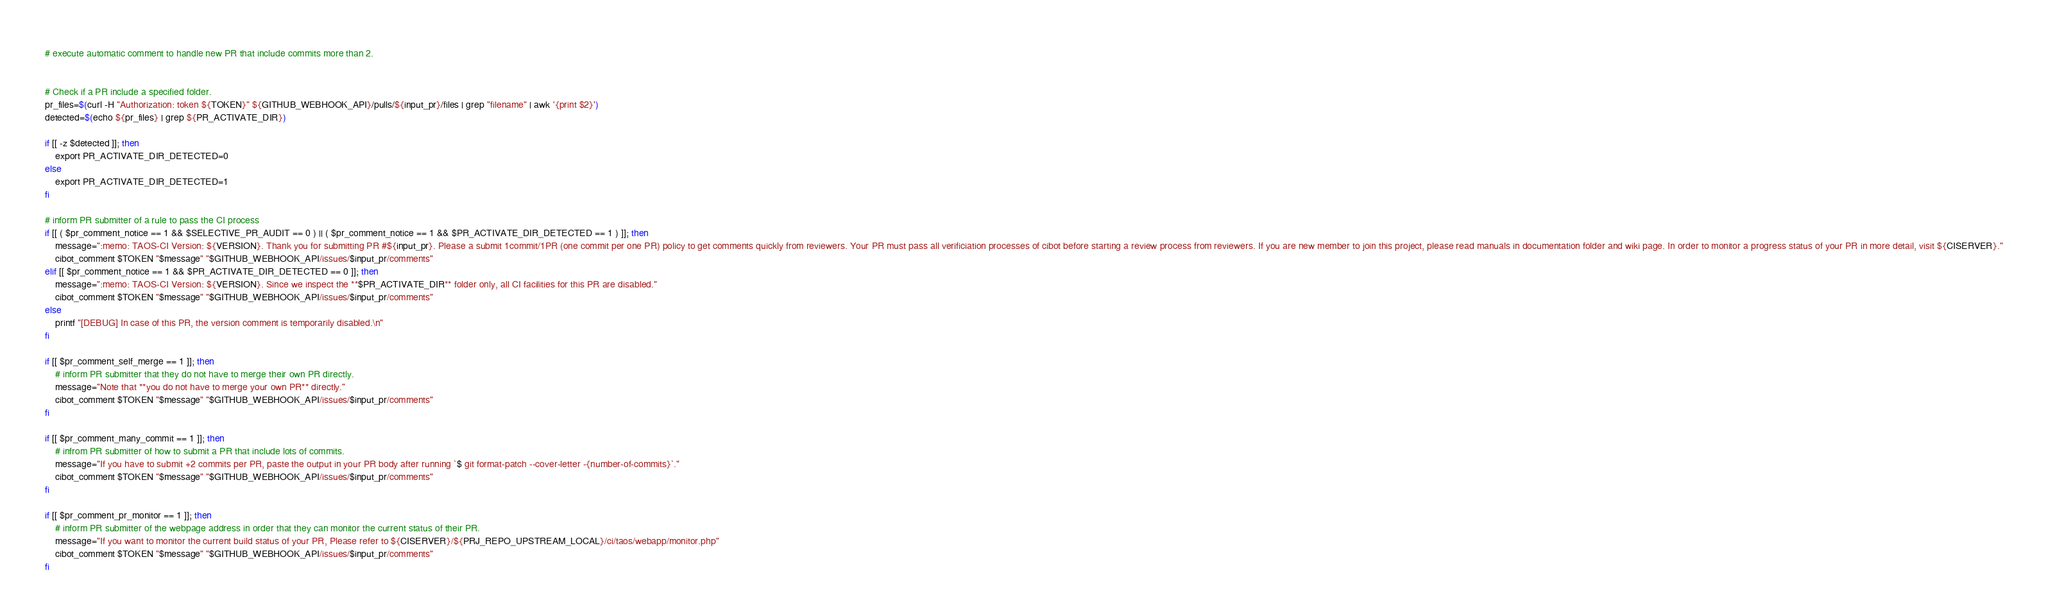<code> <loc_0><loc_0><loc_500><loc_500><_Bash_># execute automatic comment to handle new PR that include commits more than 2.


# Check if a PR include a specified folder.
pr_files=$(curl -H "Authorization: token ${TOKEN}" ${GITHUB_WEBHOOK_API}/pulls/${input_pr}/files | grep "filename" | awk '{print $2}')
detected=$(echo ${pr_files} | grep ${PR_ACTIVATE_DIR})

if [[ -z $detected ]]; then
    export PR_ACTIVATE_DIR_DETECTED=0
else
    export PR_ACTIVATE_DIR_DETECTED=1
fi

# inform PR submitter of a rule to pass the CI process
if [[ ( $pr_comment_notice == 1 && $SELECTIVE_PR_AUDIT == 0 ) || ( $pr_comment_notice == 1 && $PR_ACTIVATE_DIR_DETECTED == 1 ) ]]; then
    message=":memo: TAOS-CI Version: ${VERSION}. Thank you for submitting PR #${input_pr}. Please a submit 1commit/1PR (one commit per one PR) policy to get comments quickly from reviewers. Your PR must pass all verificiation processes of cibot before starting a review process from reviewers. If you are new member to join this project, please read manuals in documentation folder and wiki page. In order to monitor a progress status of your PR in more detail, visit ${CISERVER}."
    cibot_comment $TOKEN "$message" "$GITHUB_WEBHOOK_API/issues/$input_pr/comments"
elif [[ $pr_comment_notice == 1 && $PR_ACTIVATE_DIR_DETECTED == 0 ]]; then
    message=":memo: TAOS-CI Version: ${VERSION}. Since we inspect the **$PR_ACTIVATE_DIR** folder only, all CI facilities for this PR are disabled."
    cibot_comment $TOKEN "$message" "$GITHUB_WEBHOOK_API/issues/$input_pr/comments"
else
    printf "[DEBUG] In case of this PR, the version comment is temporarily disabled.\n"
fi

if [[ $pr_comment_self_merge == 1 ]]; then
    # inform PR submitter that they do not have to merge their own PR directly.
    message="Note that **you do not have to merge your own PR** directly."
    cibot_comment $TOKEN "$message" "$GITHUB_WEBHOOK_API/issues/$input_pr/comments"
fi

if [[ $pr_comment_many_commit == 1 ]]; then
    # infrom PR submitter of how to submit a PR that include lots of commits.
    message="If you have to submit +2 commits per PR, paste the output in your PR body after running `$ git format-patch --cover-letter -{number-of-commits}`."
    cibot_comment $TOKEN "$message" "$GITHUB_WEBHOOK_API/issues/$input_pr/comments"
fi

if [[ $pr_comment_pr_monitor == 1 ]]; then
    # inform PR submitter of the webpage address in order that they can monitor the current status of their PR.
    message="If you want to monitor the current build status of your PR, Please refer to ${CISERVER}/${PRJ_REPO_UPSTREAM_LOCAL}/ci/taos/webapp/monitor.php"
    cibot_comment $TOKEN "$message" "$GITHUB_WEBHOOK_API/issues/$input_pr/comments"
fi

</code> 